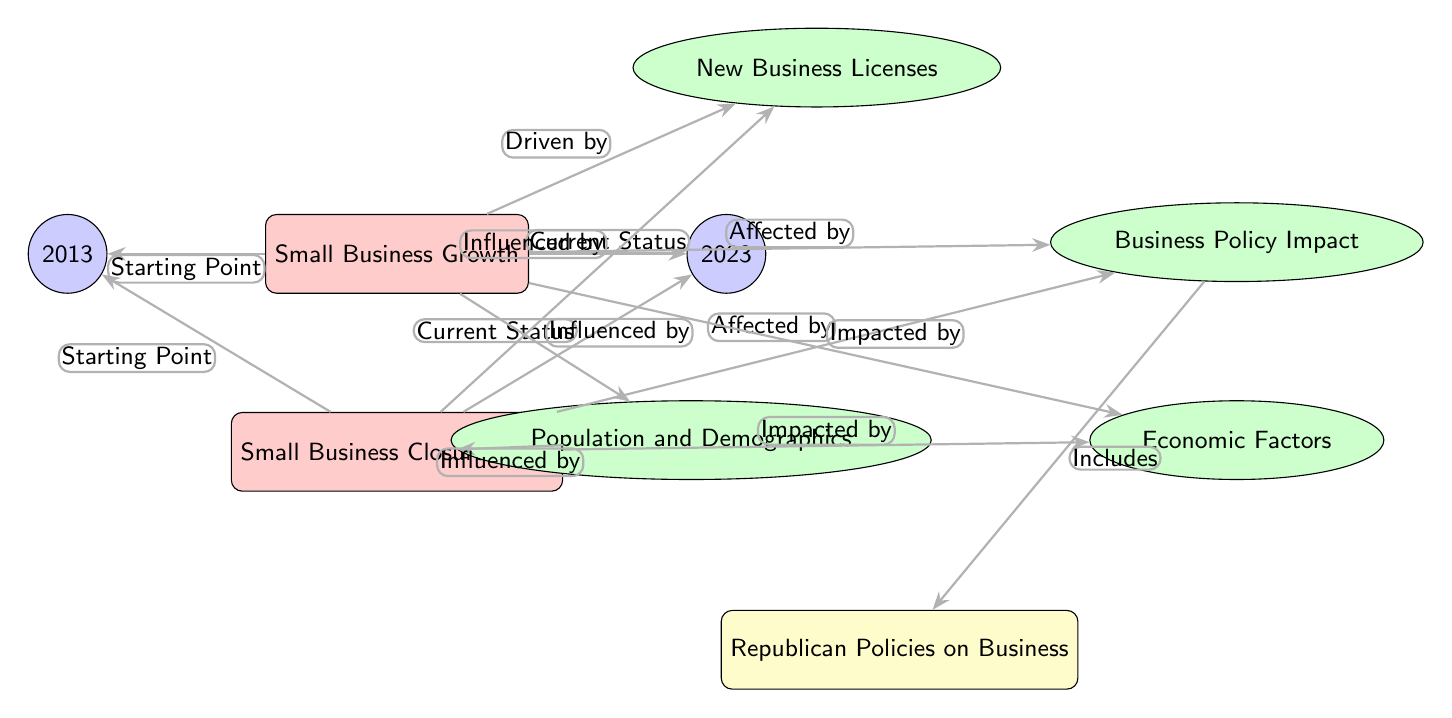What are the two main nodes in the diagram? The two main nodes are "Small Business Growth" and "Small Business Closure Rates." These represent the two primary subjects of the diagram.
Answer: Small Business Growth, Small Business Closure Rates What are the years represented in the diagram? The years represented in the diagram are 2013 and 2023, indicated by the nodes on either side of "Small Business Growth" and "Small Business Closure Rates."
Answer: 2013, 2023 What is the main factor driving small business growth according to the diagram? The main factor driving small business growth is "New Business Licenses," as indicated by the arrow leading from the growth node to this factor.
Answer: New Business Licenses What affects both small business growth and closure rates? Both small business growth and closure rates are affected by "Business Policy Impact," shown by the arrows leading to the policy node from both main nodes.
Answer: Business Policy Impact How are economic factors connected to small business dynamics? Economic factors are connected to small business dynamics as they are indicated to impact both "Small Business Growth" and "Small Business Closure Rates," based on the arrows showing these connections.
Answer: Impacted by What is included under the policy affecting small business closure rates? The policy affecting small business closure rates includes "Republican Policies on Business," indicated by the arrow connecting the policy node to the republican node.
Answer: Republican Policies on Business How many year nodes are present in the diagram? There are two year nodes present, one for 2013 and one for 2023. This can be counted directly from the diagram's layout.
Answer: 2 Which factors influence small business dynamics according to the diagram? The factors influencing small business dynamics, as shown in the diagram, are "Population and Demographics" and "Economic Factors," both of which are connected to the main nodes.
Answer: Population and Demographics, Economic Factors What is the relationship between "Small Business Growth" and "New Business Licenses"? "Small Business Growth" is driven by "New Business Licenses," as indicated by the directed arrow from the growth node toward the licenses factor.
Answer: Driven by What element is impacting small business closure rates? Small business closure rates are impacted by "Economic Factors," which are indicated to have a direct influence on the closure node in the diagram.
Answer: Economic Factors 